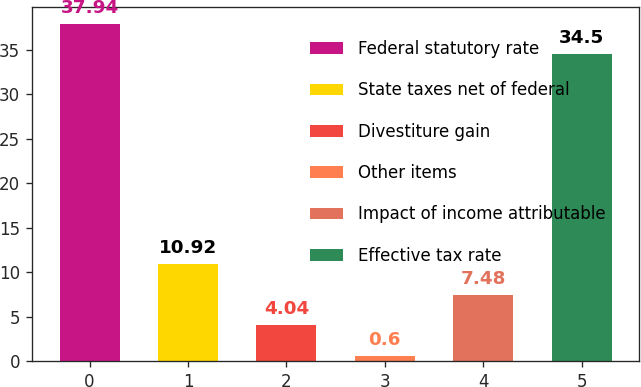<chart> <loc_0><loc_0><loc_500><loc_500><bar_chart><fcel>Federal statutory rate<fcel>State taxes net of federal<fcel>Divestiture gain<fcel>Other items<fcel>Impact of income attributable<fcel>Effective tax rate<nl><fcel>37.94<fcel>10.92<fcel>4.04<fcel>0.6<fcel>7.48<fcel>34.5<nl></chart> 